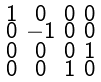<formula> <loc_0><loc_0><loc_500><loc_500>\begin{smallmatrix} 1 & 0 & 0 & 0 \\ 0 & - 1 & 0 & 0 \\ 0 & 0 & 0 & 1 \\ 0 & 0 & 1 & 0 \end{smallmatrix}</formula> 